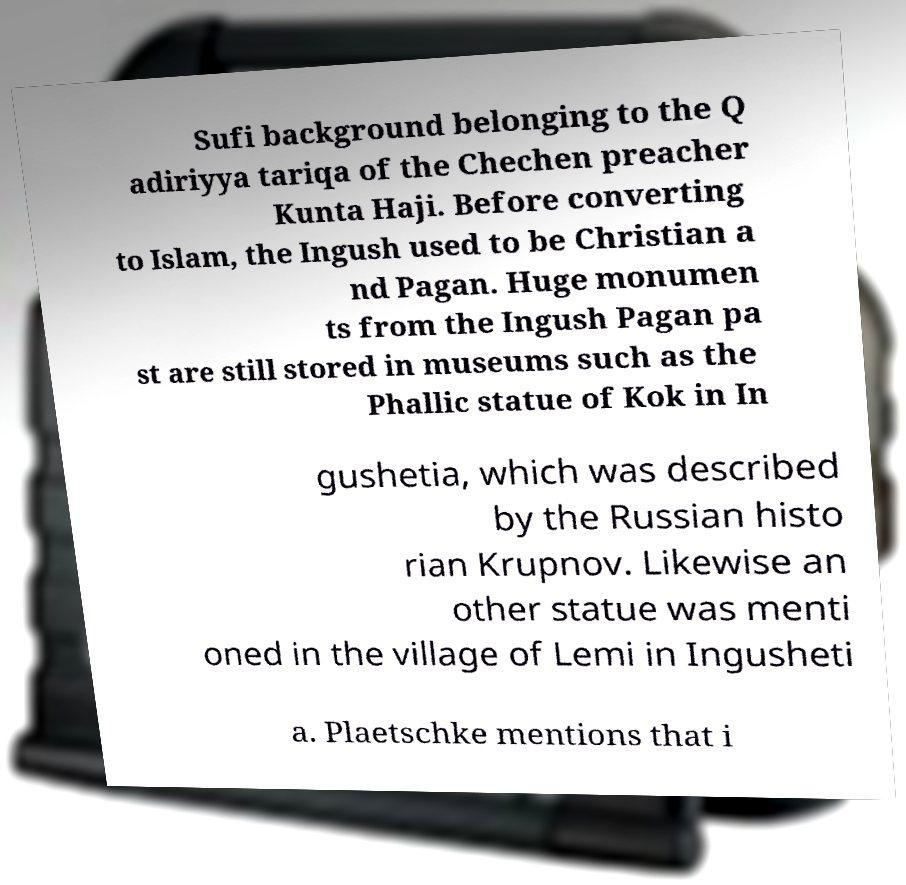Please read and relay the text visible in this image. What does it say? Sufi background belonging to the Q adiriyya tariqa of the Chechen preacher Kunta Haji. Before converting to Islam, the Ingush used to be Christian a nd Pagan. Huge monumen ts from the Ingush Pagan pa st are still stored in museums such as the Phallic statue of Kok in In gushetia, which was described by the Russian histo rian Krupnov. Likewise an other statue was menti oned in the village of Lemi in Ingusheti a. Plaetschke mentions that i 